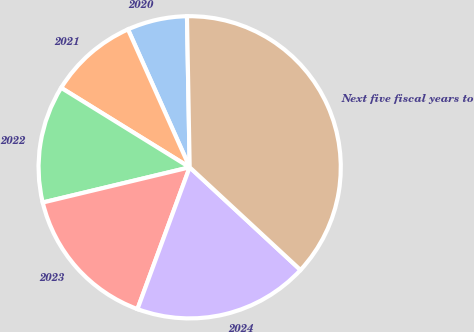Convert chart. <chart><loc_0><loc_0><loc_500><loc_500><pie_chart><fcel>2020<fcel>2021<fcel>2022<fcel>2023<fcel>2024<fcel>Next five fiscal years to<nl><fcel>6.41%<fcel>9.49%<fcel>12.56%<fcel>15.64%<fcel>18.72%<fcel>37.18%<nl></chart> 